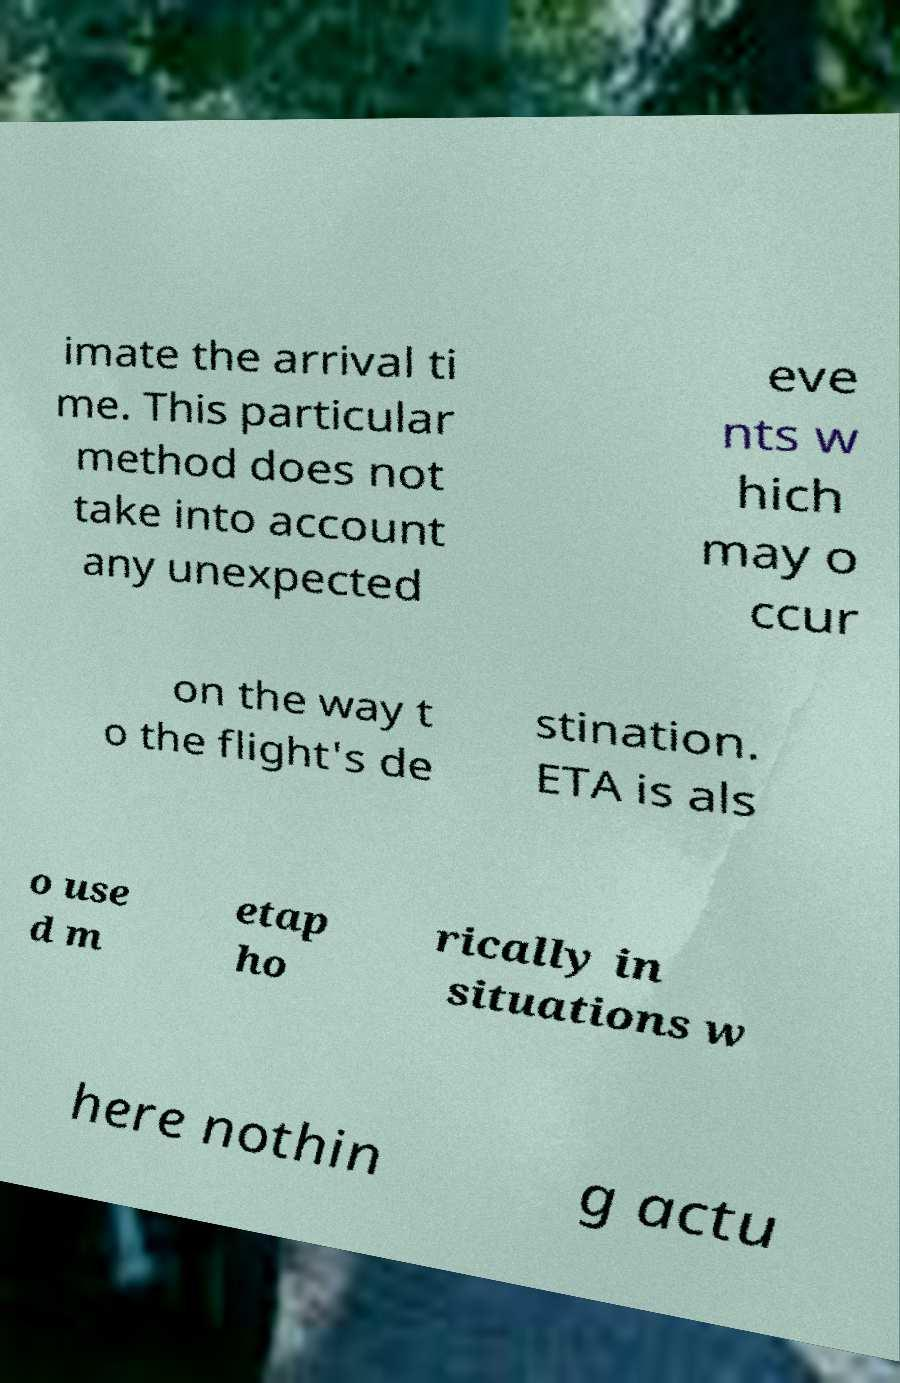Please identify and transcribe the text found in this image. imate the arrival ti me. This particular method does not take into account any unexpected eve nts w hich may o ccur on the way t o the flight's de stination. ETA is als o use d m etap ho rically in situations w here nothin g actu 